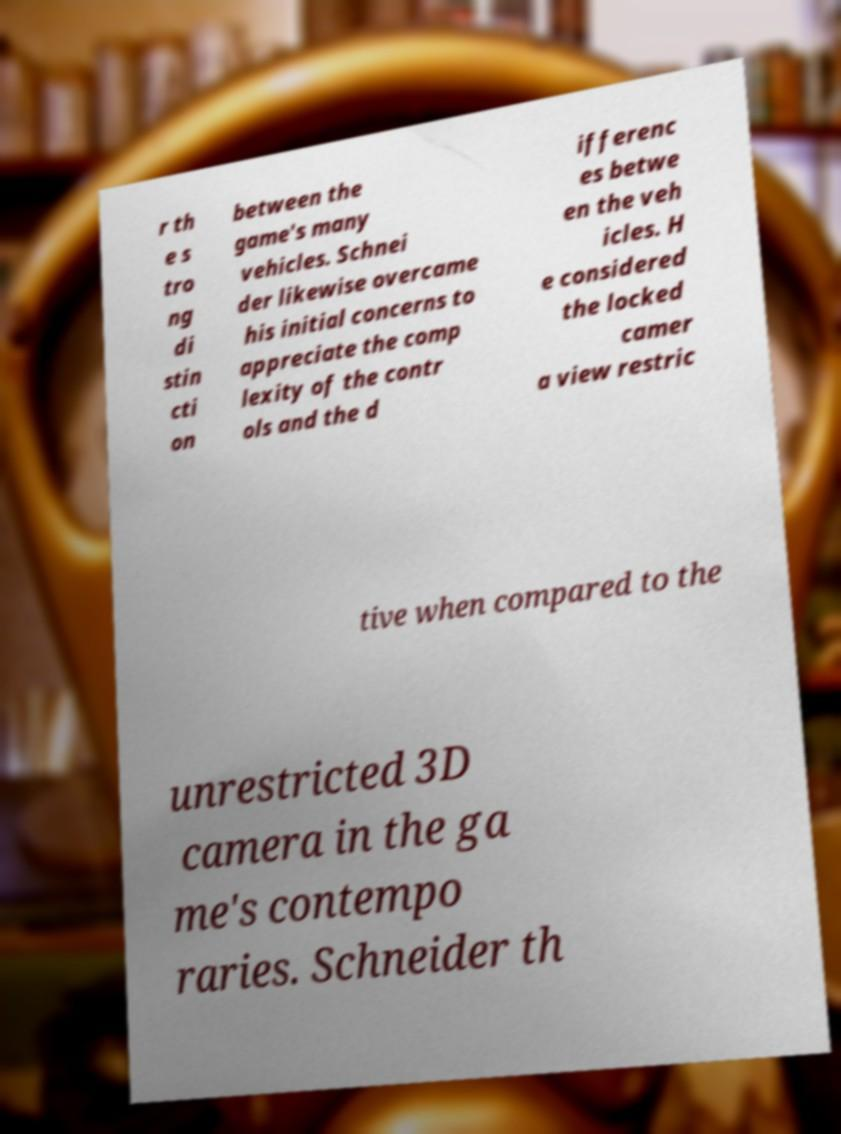Could you extract and type out the text from this image? r th e s tro ng di stin cti on between the game's many vehicles. Schnei der likewise overcame his initial concerns to appreciate the comp lexity of the contr ols and the d ifferenc es betwe en the veh icles. H e considered the locked camer a view restric tive when compared to the unrestricted 3D camera in the ga me's contempo raries. Schneider th 